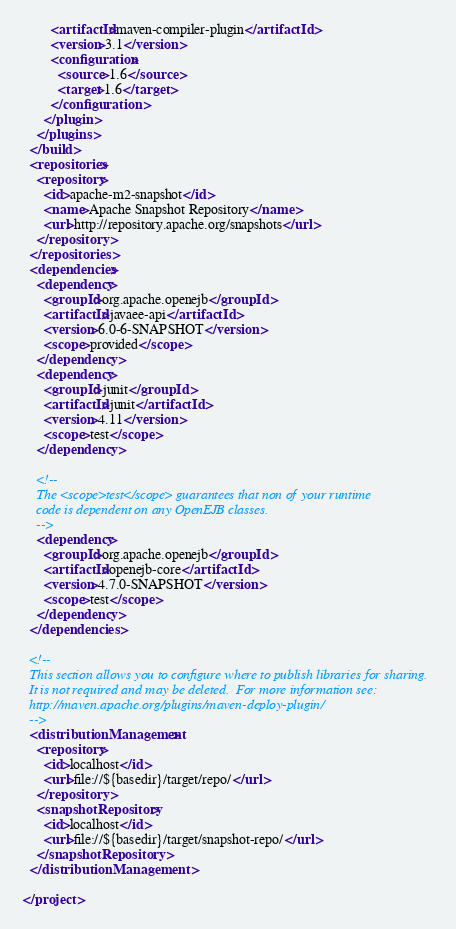Convert code to text. <code><loc_0><loc_0><loc_500><loc_500><_XML_>        <artifactId>maven-compiler-plugin</artifactId>
        <version>3.1</version>
        <configuration>
          <source>1.6</source>
          <target>1.6</target>
        </configuration>
      </plugin>
    </plugins>
  </build>
  <repositories>
    <repository>
      <id>apache-m2-snapshot</id>
      <name>Apache Snapshot Repository</name>
      <url>http://repository.apache.org/snapshots</url>
    </repository>
  </repositories>
  <dependencies>
    <dependency>
      <groupId>org.apache.openejb</groupId>
      <artifactId>javaee-api</artifactId>
      <version>6.0-6-SNAPSHOT</version>
      <scope>provided</scope>
    </dependency>
    <dependency>
      <groupId>junit</groupId>
      <artifactId>junit</artifactId>
      <version>4.11</version>
      <scope>test</scope>
    </dependency>

    <!--
    The <scope>test</scope> guarantees that non of your runtime
    code is dependent on any OpenEJB classes.
    -->
    <dependency>
      <groupId>org.apache.openejb</groupId>
      <artifactId>openejb-core</artifactId>
      <version>4.7.0-SNAPSHOT</version>
      <scope>test</scope>
    </dependency>
  </dependencies>

  <!--
  This section allows you to configure where to publish libraries for sharing.
  It is not required and may be deleted.  For more information see:
  http://maven.apache.org/plugins/maven-deploy-plugin/
  -->
  <distributionManagement>
    <repository>
      <id>localhost</id>
      <url>file://${basedir}/target/repo/</url>
    </repository>
    <snapshotRepository>
      <id>localhost</id>
      <url>file://${basedir}/target/snapshot-repo/</url>
    </snapshotRepository>
  </distributionManagement>

</project>

</code> 